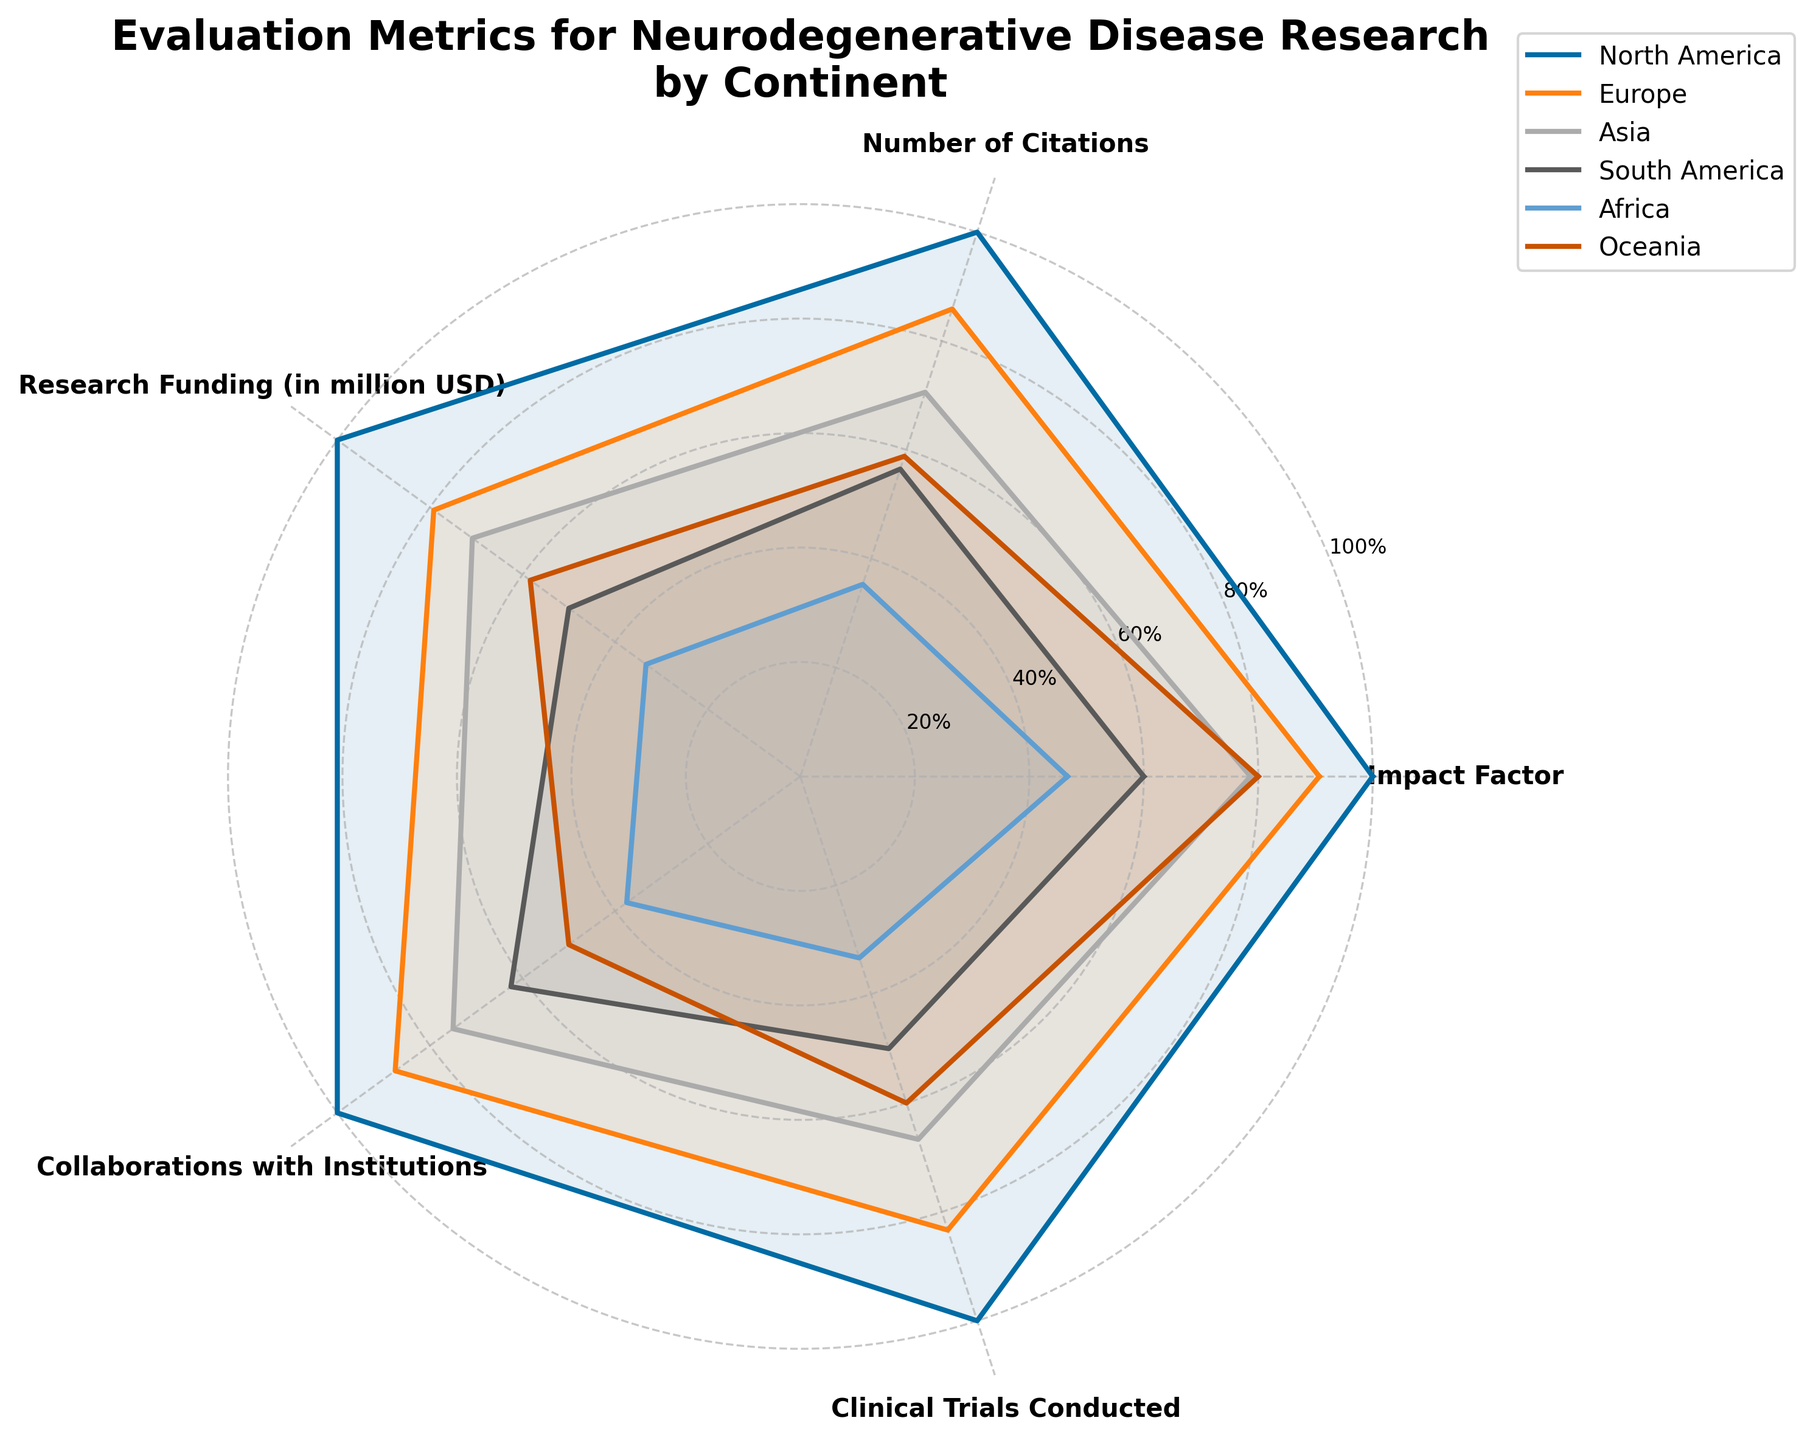What's the title of the radar chart? The title of the radar chart is found at the top center of the figure. It describes the overall topic of the visualization.
Answer: Evaluation Metrics for Neurodegenerative Disease Research by Continent Which continent shows the highest impact factor? The highest point on the 'Impact Factor' axis with a corresponding label indicates the continent with the highest impact factor.
Answer: North America Out of all the continents listed, which has the least research funding? The lowest point on the 'Research Funding' axis with a corresponding label indicates the continent with the least research funding.
Answer: Africa By how much does Europe surpass Asia in the number of citations? Look at the positions of Europe and Asia on the 'Number of Citations' axis. Then, subtract Asia's value from Europe's value to find the difference.
Answer: 130 Which two continents have the closest values in clinical trials conducted? Review the 'Clinical Trials Conducted' axis, find the points that are closest together, and identify the corresponding continents.
Answer: Asia and Oceania What is the average of North America's number of citations and clinical trials conducted? Sum North America's number of citations (850) and clinical trials conducted (30), then divide by 2 to get the average.
Answer: 440 Among the continents, which one has the most evenly distributed values across all metrics? Identify the continent whose values stay most consistent and closely follow the contour of the radar chart without significant peaks or troughs.
Answer: Europe Compare North America and South America in terms of collaborations with institutions. How many more collaborations does North America have? Look at the 'Collaborations with Institutions' axis for both continents. Subtract South America's value from North America's value to determine the difference.
Answer: 15 Which continent has a higher research funding: Oceania or Asia? By how much? Locate both continents on the 'Research Funding' axis. Subtract Asia's value from Oceania's value to find the difference.
Answer: 10 If you combine the number of clinical trials conducted in Africa and South America, what is the total? Add the number of clinical trials conducted by Africa (10) and South America (15) to get the total.
Answer: 25 